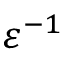<formula> <loc_0><loc_0><loc_500><loc_500>\varepsilon ^ { - 1 }</formula> 